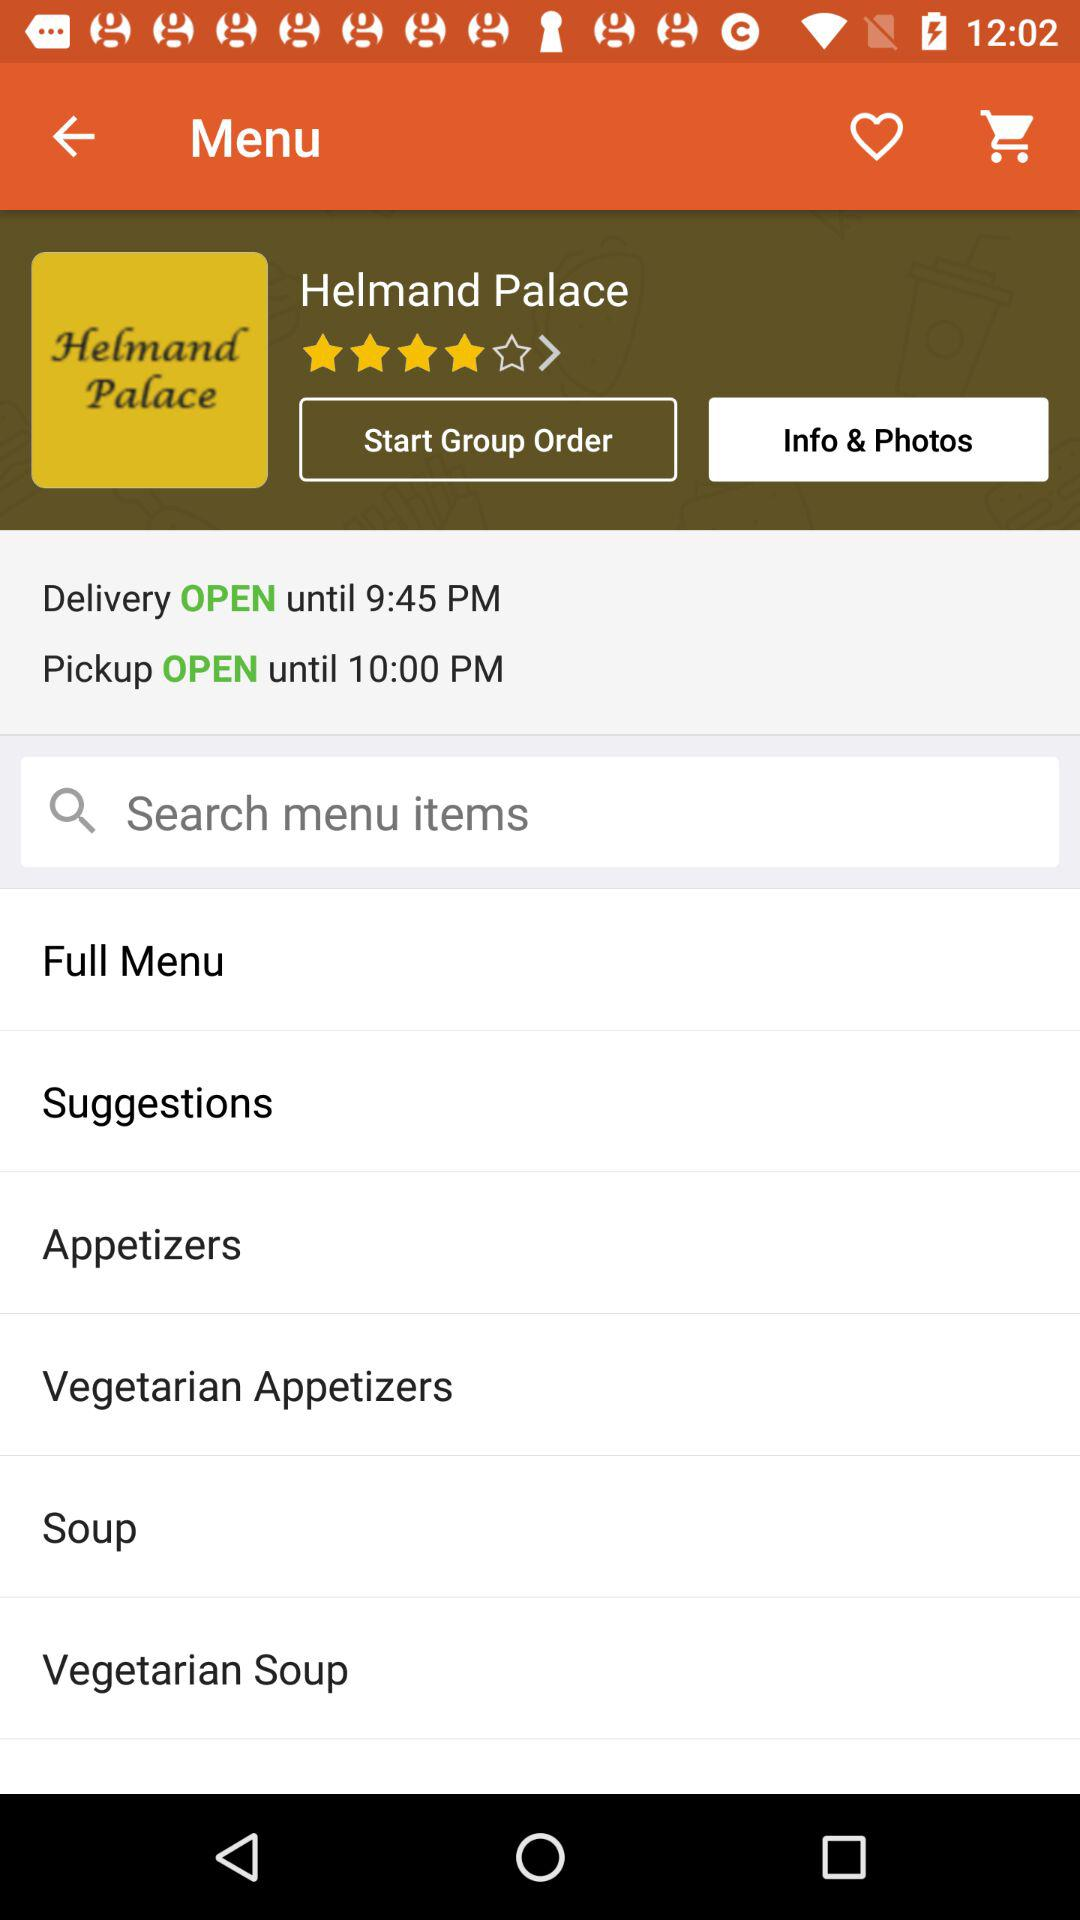What is the palace name? The palace name is "Helmand Palace". 